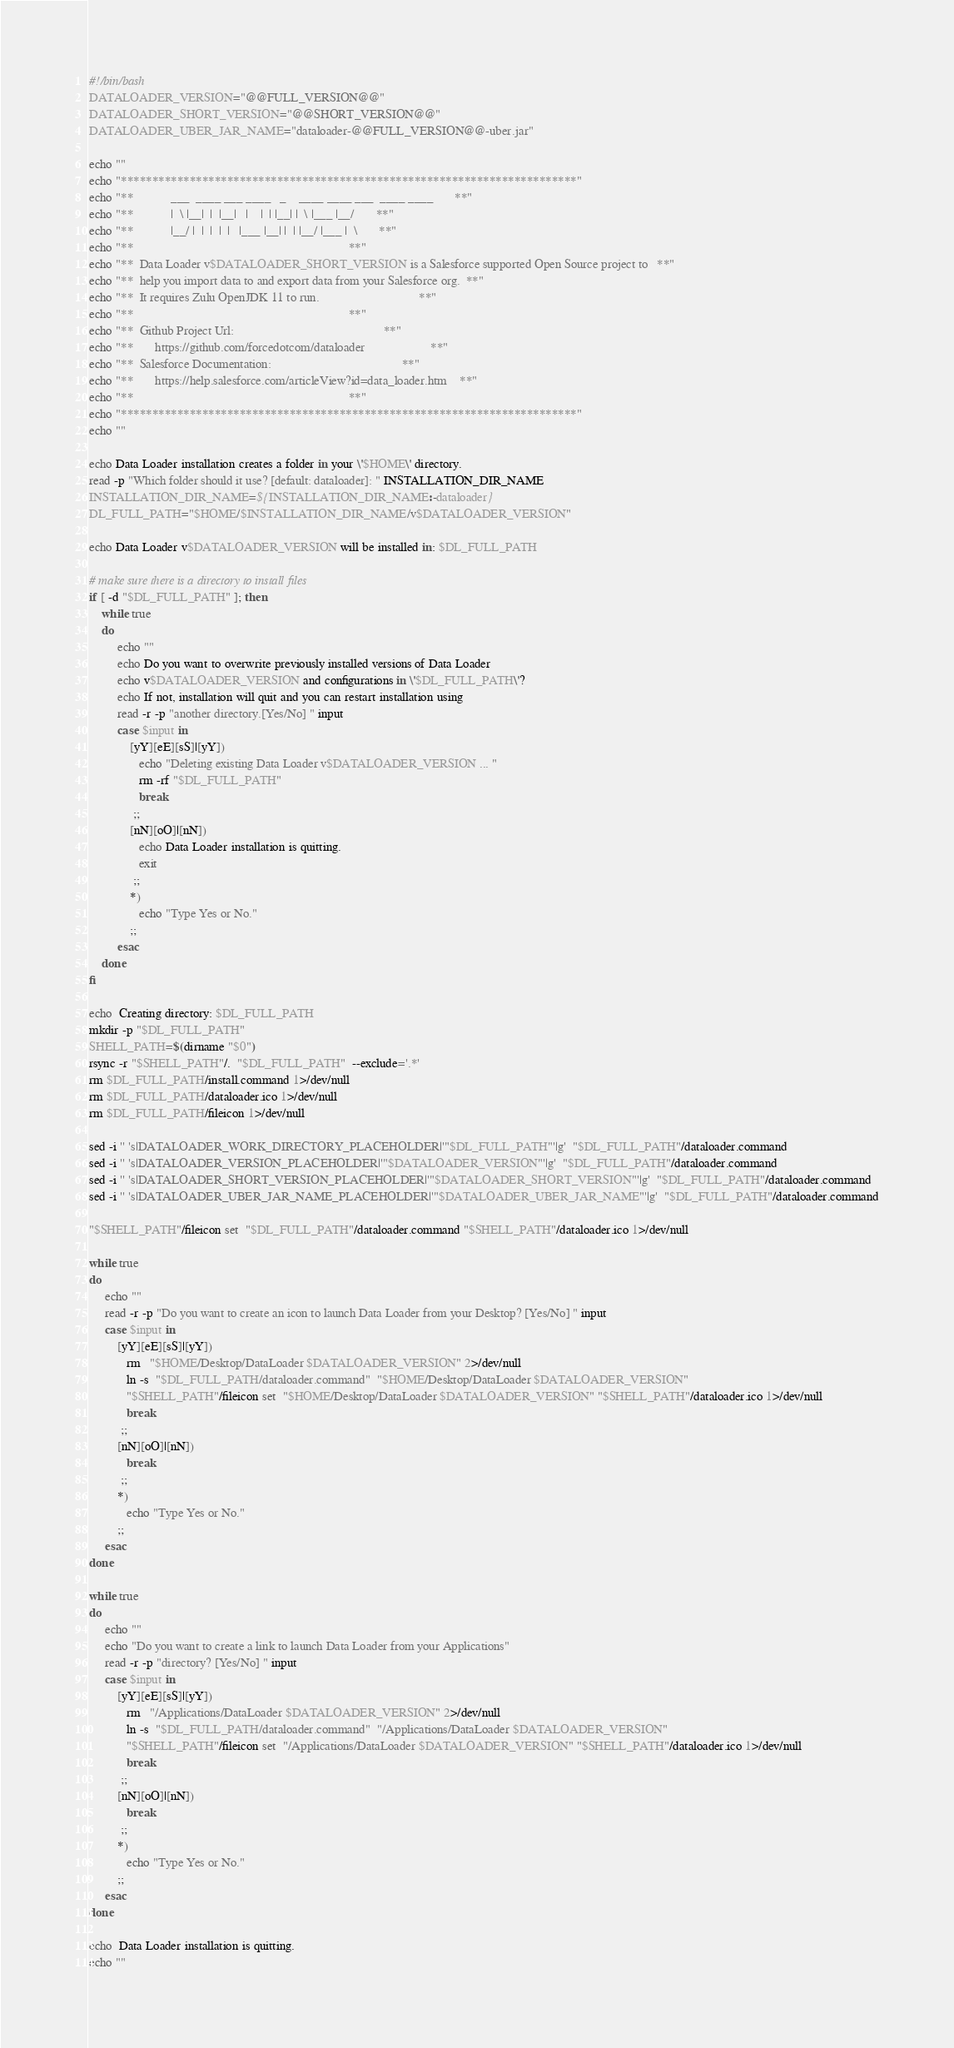<code> <loc_0><loc_0><loc_500><loc_500><_Bash_>#!/bin/bash
DATALOADER_VERSION="@@FULL_VERSION@@"
DATALOADER_SHORT_VERSION="@@SHORT_VERSION@@"
DATALOADER_UBER_JAR_NAME="dataloader-@@FULL_VERSION@@-uber.jar"

echo ""
echo "*************************************************************************"
echo "**            ___  ____ ___ ____   _    ____ ____ ___  ____ ____       **"
echo "**            |  \ |__|  |  |__|   |    |  | |__| |  \ |___ |__/       **"
echo "**            |__/ |  |  |  |  |   |___ |__| |  | |__/ |___ |  \       **"
echo "**                                                                     **"
echo "**  Data Loader v$DATALOADER_SHORT_VERSION is a Salesforce supported Open Source project to   **"
echo "**  help you import data to and export data from your Salesforce org.  **"
echo "**  It requires Zulu OpenJDK 11 to run.                                **"
echo "**                                                                     **"
echo "**  Github Project Url:                                                **"
echo "**       https://github.com/forcedotcom/dataloader                     **"
echo "**  Salesforce Documentation:                                          **"
echo "**       https://help.salesforce.com/articleView?id=data_loader.htm    **"
echo "**                                                                     **"
echo "*************************************************************************"
echo ""

echo Data Loader installation creates a folder in your \'$HOME\' directory.
read -p "Which folder should it use? [default: dataloader]: " INSTALLATION_DIR_NAME
INSTALLATION_DIR_NAME=${INSTALLATION_DIR_NAME:-dataloader}
DL_FULL_PATH="$HOME/$INSTALLATION_DIR_NAME/v$DATALOADER_VERSION"

echo Data Loader v$DATALOADER_VERSION will be installed in: $DL_FULL_PATH

# make sure there is a directory to install files
if [ -d "$DL_FULL_PATH" ]; then
    while true
    do
         echo ""
         echo Do you want to overwrite previously installed versions of Data Loader
         echo v$DATALOADER_VERSION and configurations in \'$DL_FULL_PATH\'?
         echo If not, installation will quit and you can restart installation using
         read -r -p "another directory.[Yes/No] " input
         case $input in
             [yY][eE][sS]|[yY])
                echo "Deleting existing Data Loader v$DATALOADER_VERSION ... "
                rm -rf "$DL_FULL_PATH"
                break
              ;;
             [nN][oO]|[nN])
                echo Data Loader installation is quitting.
                exit
              ;;
             *)
                echo "Type Yes or No."
             ;;
         esac
    done
fi

echo  Creating directory: $DL_FULL_PATH
mkdir -p "$DL_FULL_PATH"
SHELL_PATH=$(dirname "$0")
rsync -r "$SHELL_PATH"/.  "$DL_FULL_PATH"  --exclude='.*'
rm $DL_FULL_PATH/install.command 1>/dev/null
rm $DL_FULL_PATH/dataloader.ico 1>/dev/null
rm $DL_FULL_PATH/fileicon 1>/dev/null

sed -i '' 's|DATALOADER_WORK_DIRECTORY_PLACEHOLDER|'"$DL_FULL_PATH"'|g'  "$DL_FULL_PATH"/dataloader.command
sed -i '' 's|DATALOADER_VERSION_PLACEHOLDER|'"$DATALOADER_VERSION"'|g'  "$DL_FULL_PATH"/dataloader.command
sed -i '' 's|DATALOADER_SHORT_VERSION_PLACEHOLDER|'"$DATALOADER_SHORT_VERSION"'|g'  "$DL_FULL_PATH"/dataloader.command
sed -i '' 's|DATALOADER_UBER_JAR_NAME_PLACEHOLDER|'"$DATALOADER_UBER_JAR_NAME"'|g'  "$DL_FULL_PATH"/dataloader.command

"$SHELL_PATH"/fileicon set  "$DL_FULL_PATH"/dataloader.command "$SHELL_PATH"/dataloader.ico 1>/dev/null

while true
do
     echo ""
     read -r -p "Do you want to create an icon to launch Data Loader from your Desktop? [Yes/No] " input
     case $input in
         [yY][eE][sS]|[yY])
            rm   "$HOME/Desktop/DataLoader $DATALOADER_VERSION" 2>/dev/null
            ln -s  "$DL_FULL_PATH/dataloader.command"  "$HOME/Desktop/DataLoader $DATALOADER_VERSION"
            "$SHELL_PATH"/fileicon set  "$HOME/Desktop/DataLoader $DATALOADER_VERSION" "$SHELL_PATH"/dataloader.ico 1>/dev/null
            break
          ;;
         [nN][oO]|[nN])
            break
          ;;
         *)
            echo "Type Yes or No."
         ;;
     esac
done

while true
do
     echo ""
     echo "Do you want to create a link to launch Data Loader from your Applications"
     read -r -p "directory? [Yes/No] " input
     case $input in
         [yY][eE][sS]|[yY])
            rm   "/Applications/DataLoader $DATALOADER_VERSION" 2>/dev/null
            ln -s  "$DL_FULL_PATH/dataloader.command"  "/Applications/DataLoader $DATALOADER_VERSION"
            "$SHELL_PATH"/fileicon set  "/Applications/DataLoader $DATALOADER_VERSION" "$SHELL_PATH"/dataloader.ico 1>/dev/null
            break
          ;;
         [nN][oO]|[nN])
            break
          ;;
         *)
            echo "Type Yes or No."
         ;;
     esac
done

echo  Data Loader installation is quitting.
echo ""
</code> 